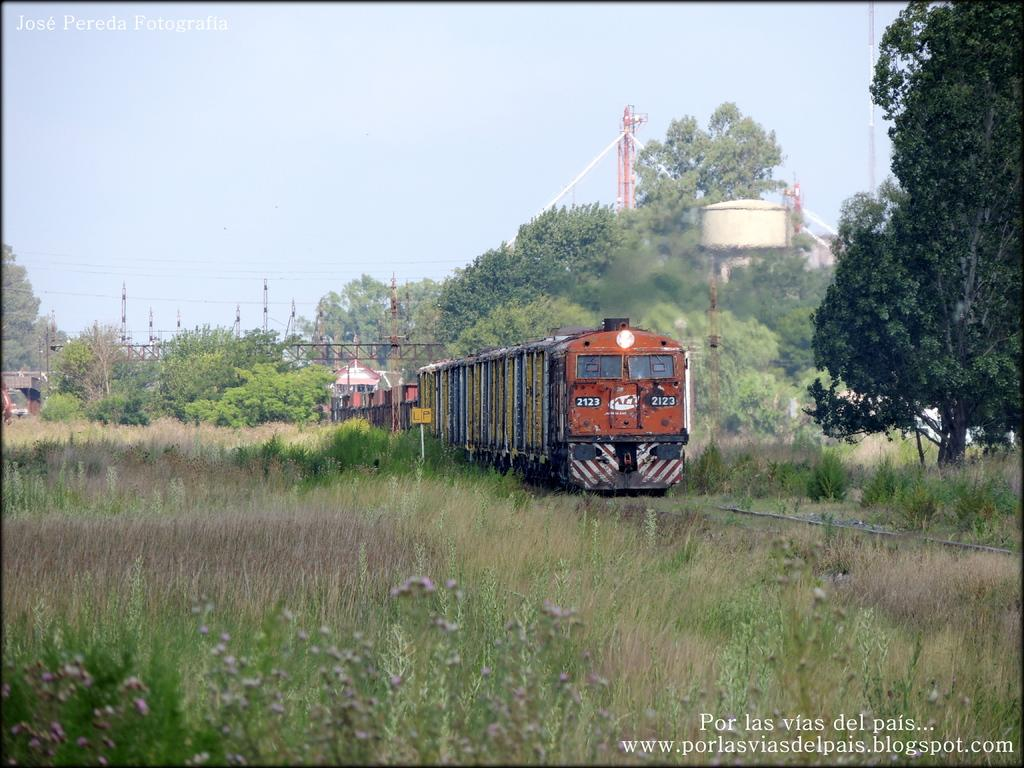<image>
Share a concise interpretation of the image provided. Train number 2123 moves on rails hidden by tall weeds. 